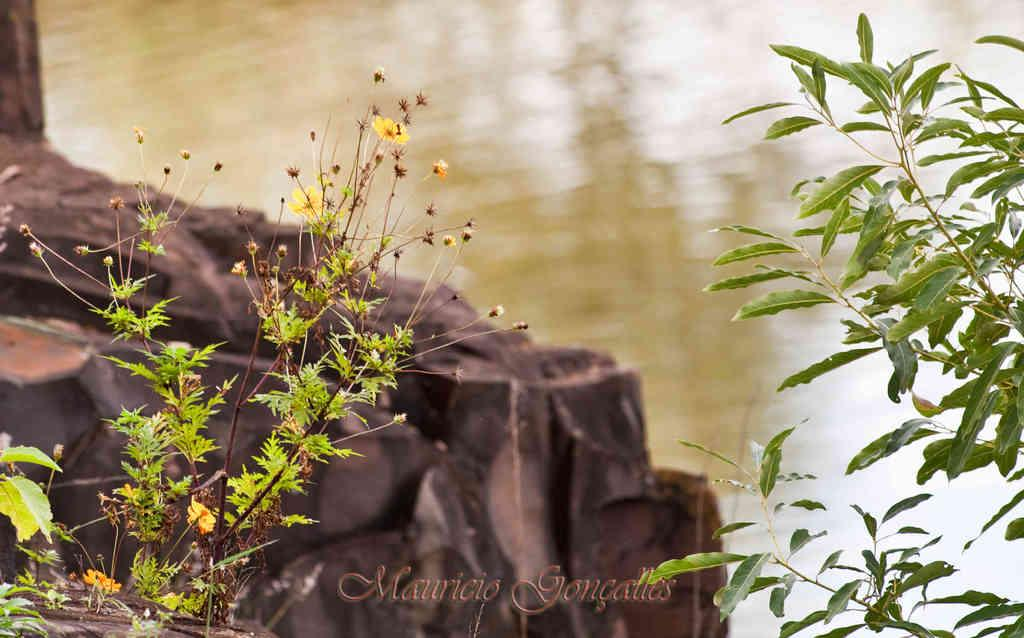What type of living organisms can be seen in the image? Plants can be seen in the image. What other elements can be seen in the image? There are rocks and water visible in the image. Is there any text present in the image? Yes, there is some text on the bottom of the image. What type of bun is being prepared in the image? There is no bun present in the image. 